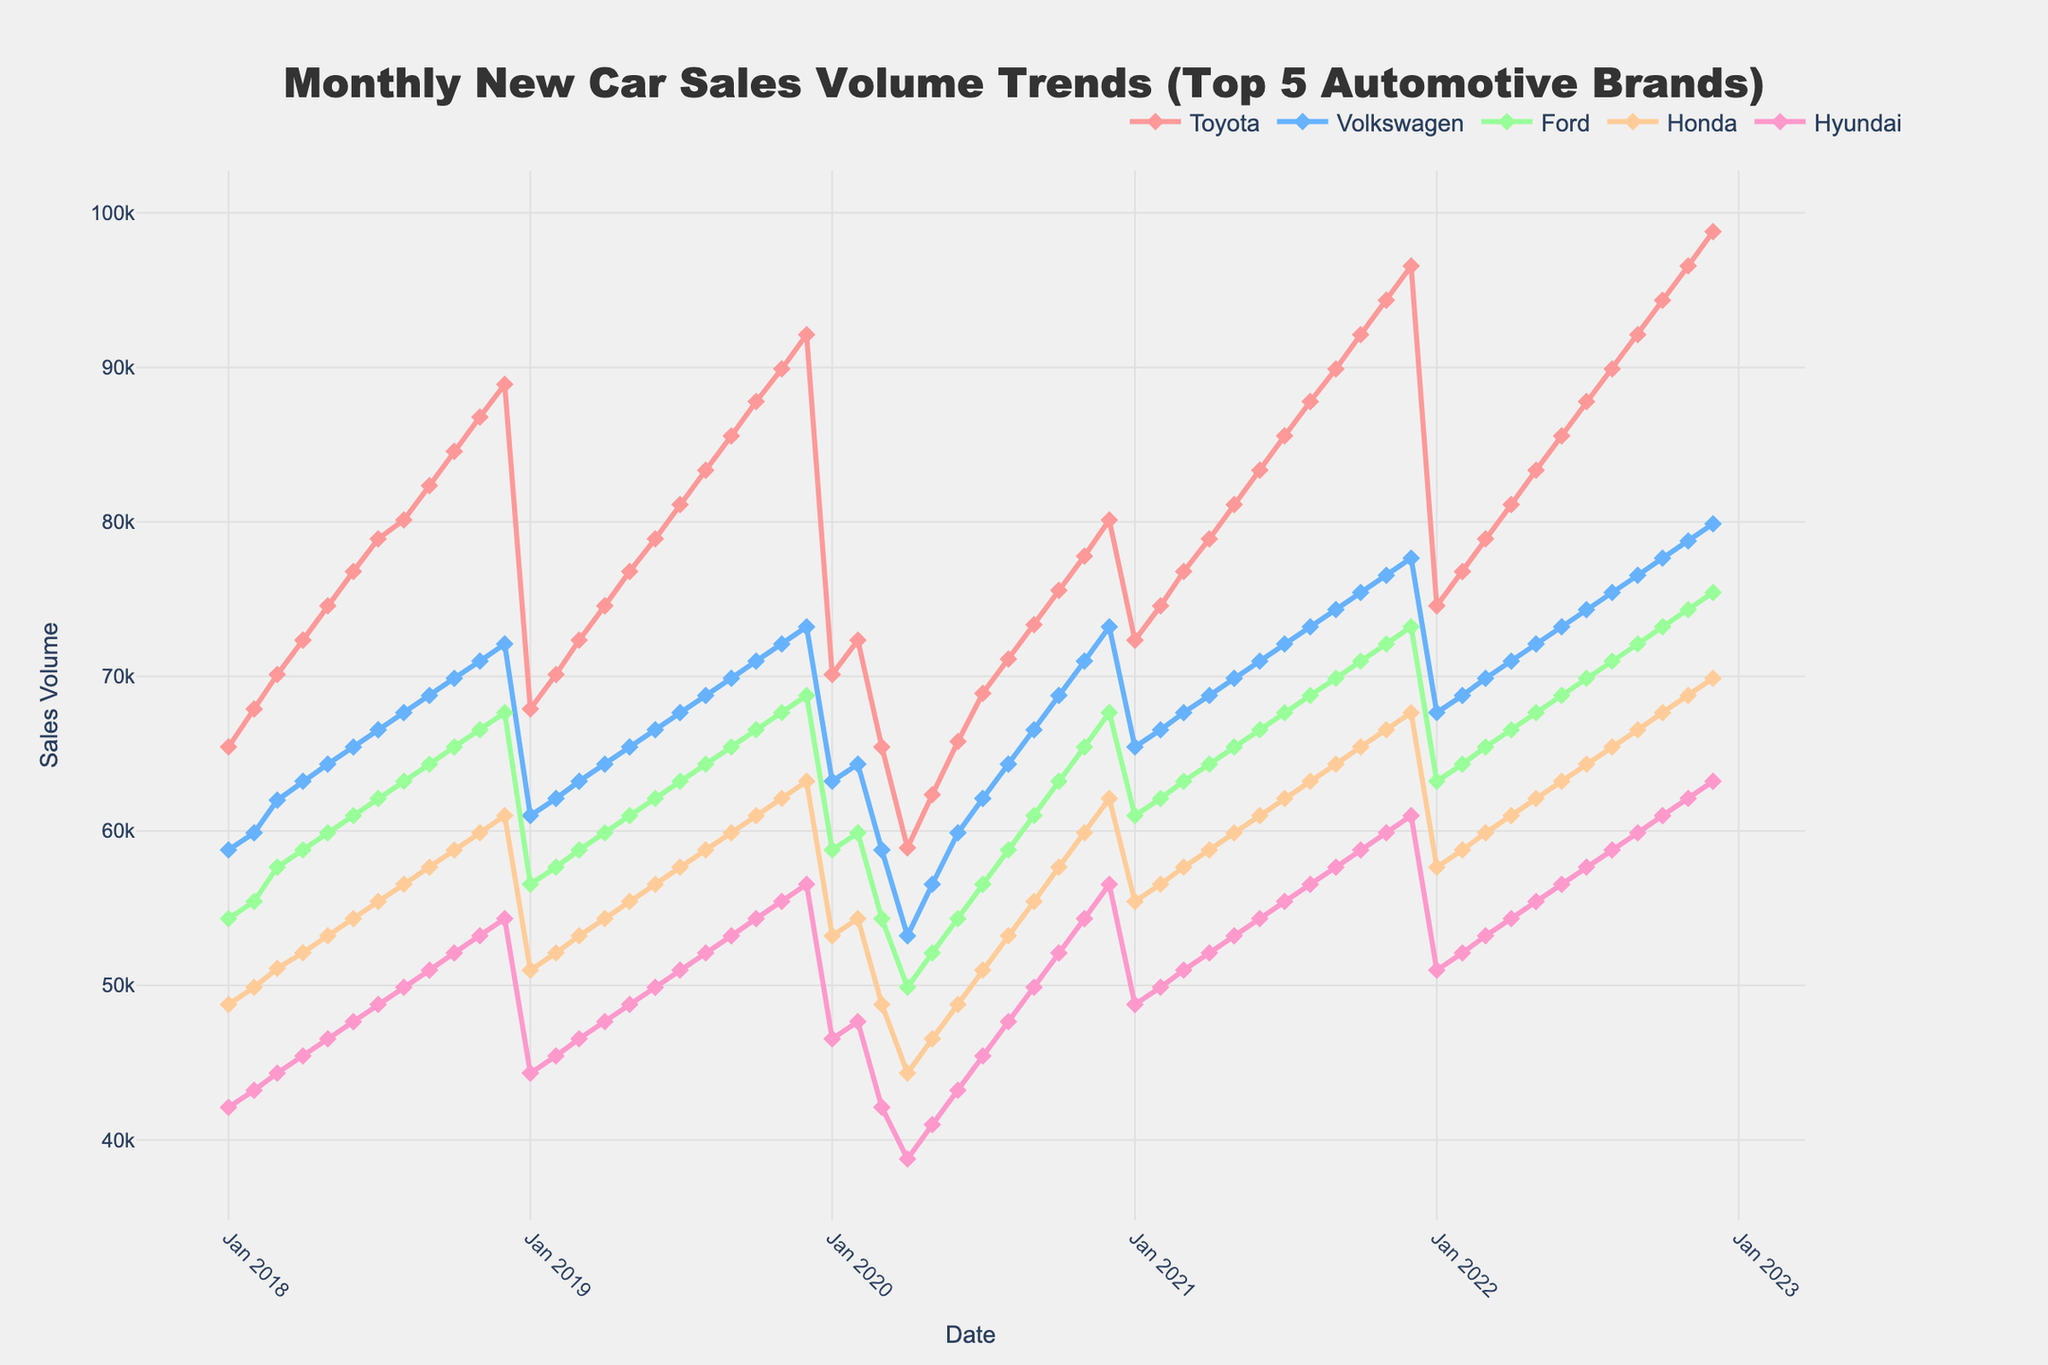What was the trend of Toyota sales volume in 2020? The figure shows a decline in Toyota's sales volume from January to April 2020, followed by a steady increase till December 2020. January started around 70,123 units, April hit the lowest at approximately 58,901 units, and December peaked at about 80,123 units.
Answer: Decline followed by increase How did Hyundai's sales volume in December 2022 compare to December 2018? In December 2018, Hyundai's sales were approximately 54,321 units. In December 2022, Hyundai's sales were around 63,210 units. Hence, Hyundai's sales increased from December 2018 to December 2022.
Answer: Increased Which brand had the highest sales volume in December 2021, and what was the value? Observing the figure, Toyota had the highest sales volume in December 2021 among the brands, with the volume being approximately 96,567 units.
Answer: Toyota - 96,567 units At what time did Ford's sales volume show a significant drop, and what could be inferred from it? Ford's sales volume showed a significant drop around March to April 2020. The volume went from approximately 54,321 units in March to around 49,876 units in April, likely due to the effects of the COVID-19 pandemic.
Answer: March-April 2020, likely due to COVID-19 Between 2019 and 2020, how did Volkswagen's sales change in the month of February? In February 2019, Volkswagen's sales volume was approximately 62,098 units. In February 2020, the sales volume was around 64,321 units. This shows an increase in Volkswagen's sales between February 2019 and February 2020.
Answer: Increased Which brand showed a consistent increase in sales volume from January 2018 to December 2022 and how is it visually depicted? Toyota showed a consistent increase in sales volume from January 2018 to December 2022. Visually, it is depicted by the upward sloping line with markers rising each year.
Answer: Toyota, upward sloping line Compare the sales trend of Honda and Hyundai in 2021. Honda and Hyundai both showed an increasing sales trend throughout 2021. Their sales lines both rise from January to December 2021, with steady growth and following a similar pattern of monthly increases.
Answer: Both increased During which year did all five brands show a dip in sales, and what major global event could this correlate with? All five brands showed a dip in sales around April 2020. This correlates with the global impact of the COVID-19 pandemic, which disrupted manufacturing and consumer behavior.
Answer: 2020, COVID-19 pandemic Calculate the average sales volume of Ford in 2019. The monthly sales volumes for Ford in 2019 were: 56,543; 57,654; 58,765; 59,876; 60,987; 62,098; 63,210; 64,321; 65,432; 66,543; 67,654; 68,765. Summing these gives: 751,848. Average = 751,848 / 12. Hence, the average sales volume is approximately 62,654 units.
Answer: 62,654 units 